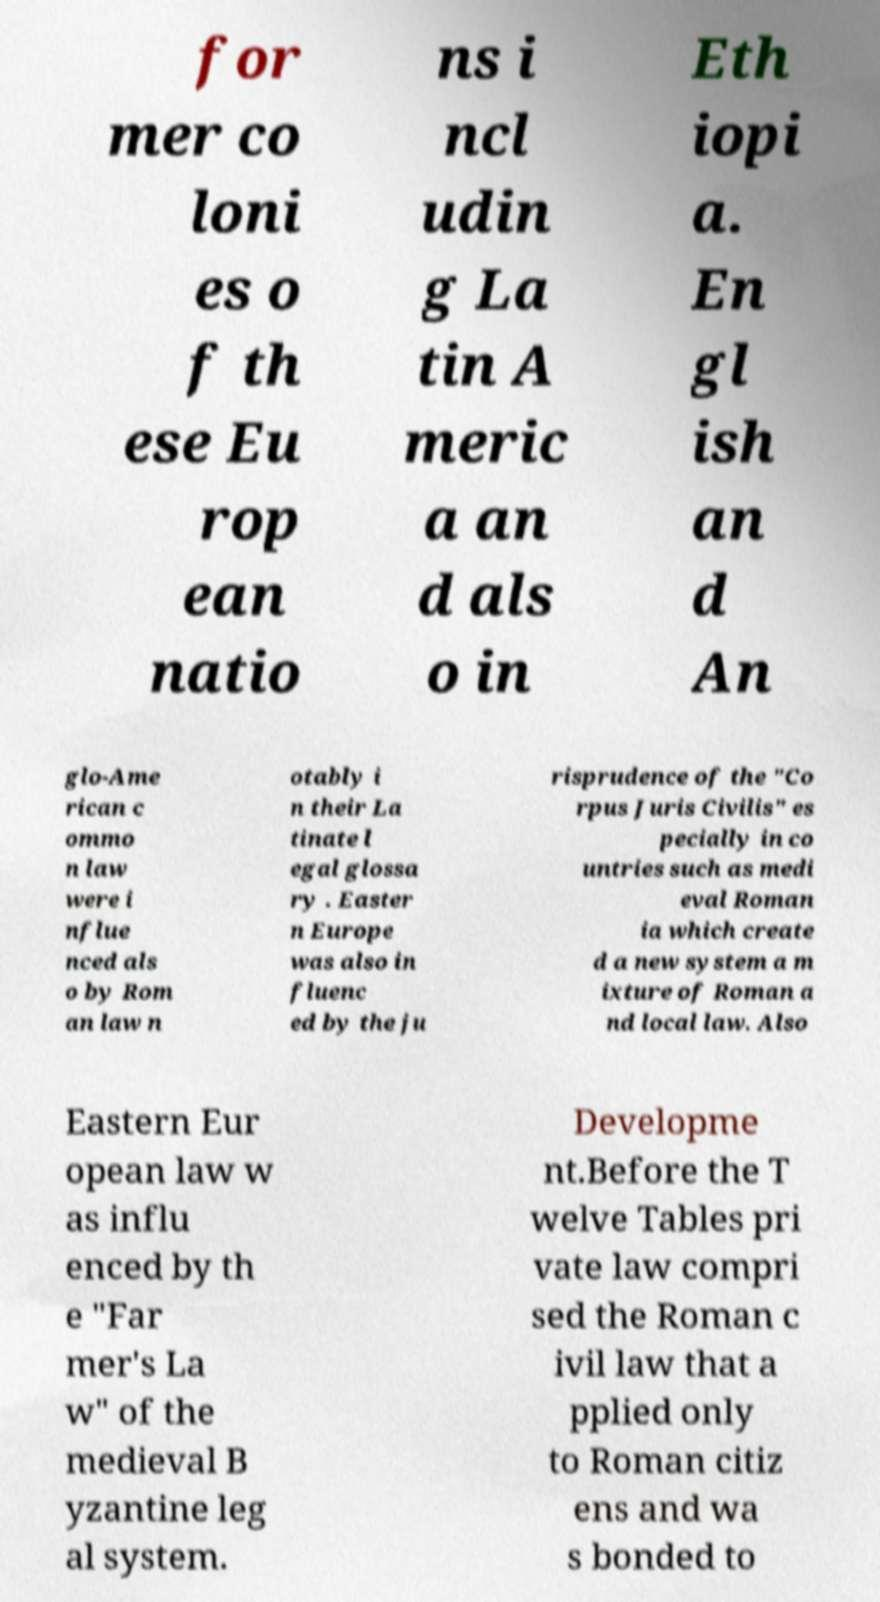Can you read and provide the text displayed in the image?This photo seems to have some interesting text. Can you extract and type it out for me? for mer co loni es o f th ese Eu rop ean natio ns i ncl udin g La tin A meric a an d als o in Eth iopi a. En gl ish an d An glo-Ame rican c ommo n law were i nflue nced als o by Rom an law n otably i n their La tinate l egal glossa ry . Easter n Europe was also in fluenc ed by the ju risprudence of the "Co rpus Juris Civilis" es pecially in co untries such as medi eval Roman ia which create d a new system a m ixture of Roman a nd local law. Also Eastern Eur opean law w as influ enced by th e "Far mer's La w" of the medieval B yzantine leg al system. Developme nt.Before the T welve Tables pri vate law compri sed the Roman c ivil law that a pplied only to Roman citiz ens and wa s bonded to 